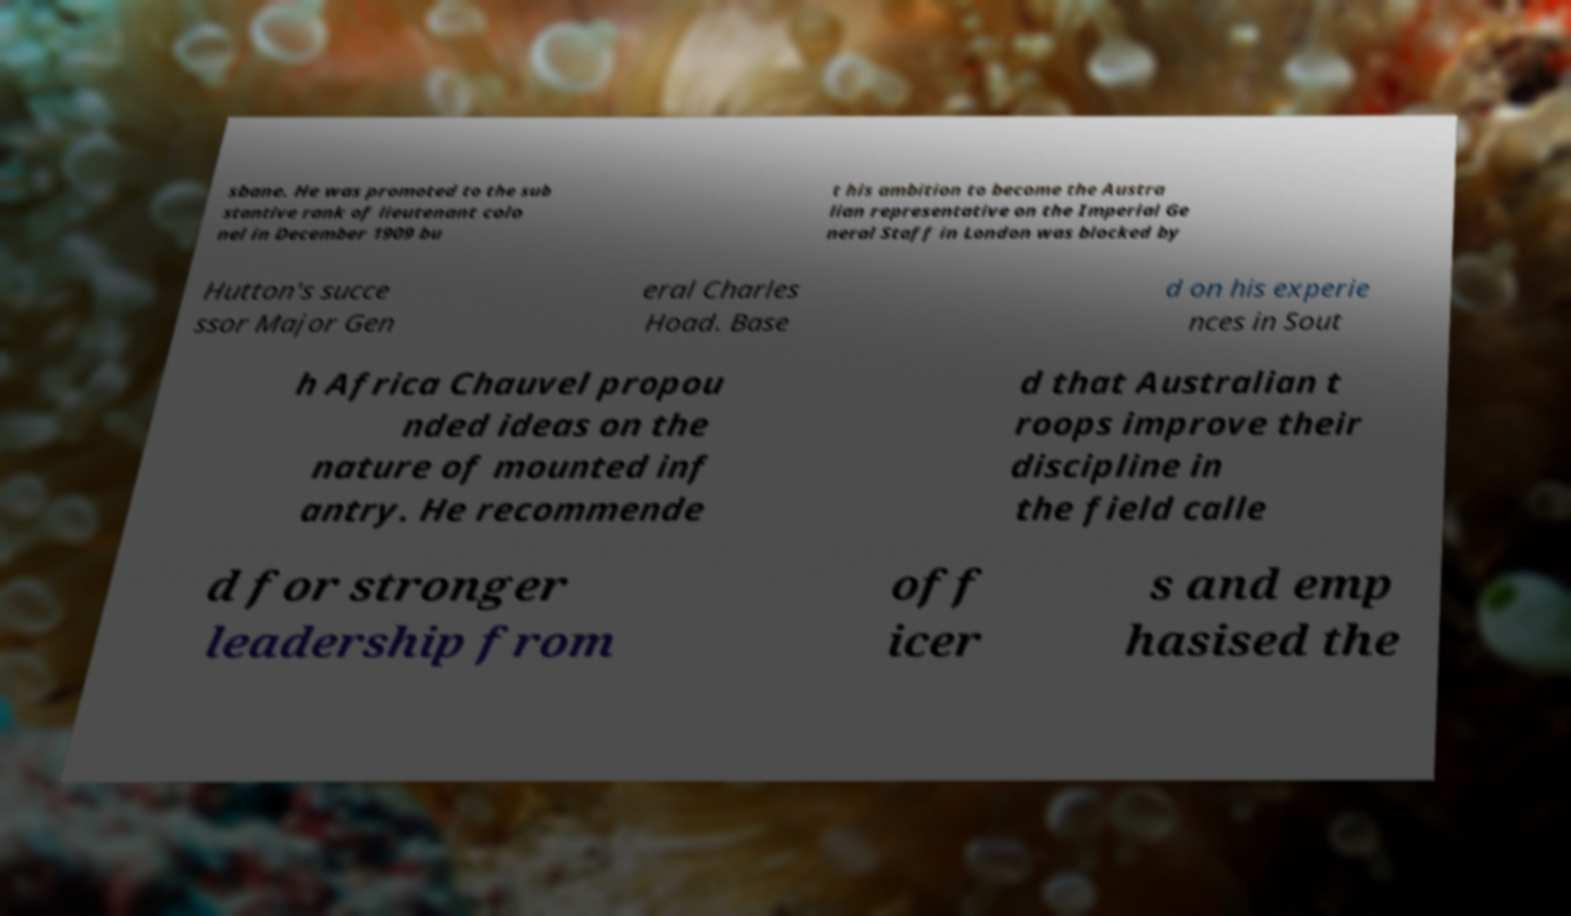There's text embedded in this image that I need extracted. Can you transcribe it verbatim? sbane. He was promoted to the sub stantive rank of lieutenant colo nel in December 1909 bu t his ambition to become the Austra lian representative on the Imperial Ge neral Staff in London was blocked by Hutton's succe ssor Major Gen eral Charles Hoad. Base d on his experie nces in Sout h Africa Chauvel propou nded ideas on the nature of mounted inf antry. He recommende d that Australian t roops improve their discipline in the field calle d for stronger leadership from off icer s and emp hasised the 